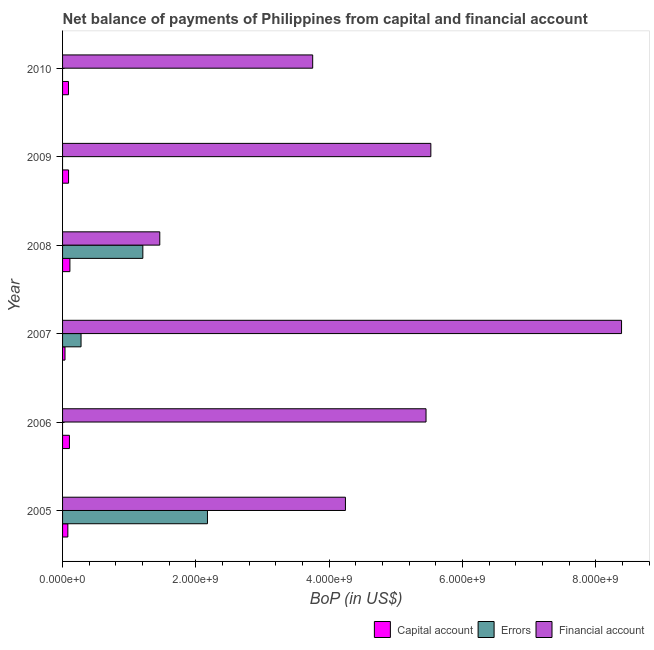How many groups of bars are there?
Give a very brief answer. 6. Are the number of bars per tick equal to the number of legend labels?
Ensure brevity in your answer.  No. How many bars are there on the 3rd tick from the top?
Your response must be concise. 3. What is the label of the 5th group of bars from the top?
Give a very brief answer. 2006. What is the amount of net capital account in 2009?
Your response must be concise. 8.99e+07. Across all years, what is the maximum amount of net capital account?
Offer a terse response. 1.10e+08. What is the total amount of financial account in the graph?
Your answer should be very brief. 2.88e+1. What is the difference between the amount of financial account in 2009 and that in 2010?
Ensure brevity in your answer.  1.77e+09. What is the difference between the amount of financial account in 2008 and the amount of net capital account in 2009?
Give a very brief answer. 1.37e+09. What is the average amount of errors per year?
Make the answer very short. 6.09e+08. In the year 2008, what is the difference between the amount of financial account and amount of net capital account?
Your response must be concise. 1.35e+09. What is the ratio of the amount of financial account in 2007 to that in 2010?
Provide a short and direct response. 2.23. Is the amount of net capital account in 2006 less than that in 2008?
Ensure brevity in your answer.  Yes. What is the difference between the highest and the second highest amount of net capital account?
Provide a short and direct response. 6.96e+06. What is the difference between the highest and the lowest amount of errors?
Ensure brevity in your answer.  2.17e+09. Is the sum of the amount of financial account in 2006 and 2009 greater than the maximum amount of errors across all years?
Offer a very short reply. Yes. Is it the case that in every year, the sum of the amount of net capital account and amount of errors is greater than the amount of financial account?
Your answer should be very brief. No. Are all the bars in the graph horizontal?
Offer a very short reply. Yes. How many years are there in the graph?
Make the answer very short. 6. Does the graph contain grids?
Keep it short and to the point. No. Where does the legend appear in the graph?
Ensure brevity in your answer.  Bottom right. How many legend labels are there?
Give a very brief answer. 3. What is the title of the graph?
Keep it short and to the point. Net balance of payments of Philippines from capital and financial account. What is the label or title of the X-axis?
Keep it short and to the point. BoP (in US$). What is the label or title of the Y-axis?
Provide a short and direct response. Year. What is the BoP (in US$) of Capital account in 2005?
Your answer should be very brief. 7.93e+07. What is the BoP (in US$) of Errors in 2005?
Your answer should be compact. 2.17e+09. What is the BoP (in US$) of Financial account in 2005?
Your answer should be very brief. 4.24e+09. What is the BoP (in US$) of Capital account in 2006?
Make the answer very short. 1.03e+08. What is the BoP (in US$) in Errors in 2006?
Make the answer very short. 0. What is the BoP (in US$) of Financial account in 2006?
Provide a short and direct response. 5.45e+09. What is the BoP (in US$) in Capital account in 2007?
Your response must be concise. 3.64e+07. What is the BoP (in US$) in Errors in 2007?
Offer a very short reply. 2.77e+08. What is the BoP (in US$) of Financial account in 2007?
Make the answer very short. 8.39e+09. What is the BoP (in US$) of Capital account in 2008?
Your answer should be compact. 1.10e+08. What is the BoP (in US$) in Errors in 2008?
Your response must be concise. 1.20e+09. What is the BoP (in US$) in Financial account in 2008?
Your response must be concise. 1.46e+09. What is the BoP (in US$) in Capital account in 2009?
Ensure brevity in your answer.  8.99e+07. What is the BoP (in US$) in Errors in 2009?
Your response must be concise. 0. What is the BoP (in US$) in Financial account in 2009?
Your answer should be very brief. 5.52e+09. What is the BoP (in US$) of Capital account in 2010?
Offer a very short reply. 8.85e+07. What is the BoP (in US$) of Errors in 2010?
Your answer should be compact. 0. What is the BoP (in US$) of Financial account in 2010?
Make the answer very short. 3.75e+09. Across all years, what is the maximum BoP (in US$) in Capital account?
Offer a terse response. 1.10e+08. Across all years, what is the maximum BoP (in US$) in Errors?
Your answer should be very brief. 2.17e+09. Across all years, what is the maximum BoP (in US$) of Financial account?
Ensure brevity in your answer.  8.39e+09. Across all years, what is the minimum BoP (in US$) in Capital account?
Make the answer very short. 3.64e+07. Across all years, what is the minimum BoP (in US$) of Financial account?
Make the answer very short. 1.46e+09. What is the total BoP (in US$) of Capital account in the graph?
Provide a succinct answer. 5.07e+08. What is the total BoP (in US$) in Errors in the graph?
Your answer should be compact. 3.66e+09. What is the total BoP (in US$) in Financial account in the graph?
Your answer should be very brief. 2.88e+1. What is the difference between the BoP (in US$) in Capital account in 2005 and that in 2006?
Your answer should be very brief. -2.38e+07. What is the difference between the BoP (in US$) of Financial account in 2005 and that in 2006?
Give a very brief answer. -1.21e+09. What is the difference between the BoP (in US$) of Capital account in 2005 and that in 2007?
Make the answer very short. 4.28e+07. What is the difference between the BoP (in US$) of Errors in 2005 and that in 2007?
Offer a terse response. 1.90e+09. What is the difference between the BoP (in US$) in Financial account in 2005 and that in 2007?
Make the answer very short. -4.14e+09. What is the difference between the BoP (in US$) in Capital account in 2005 and that in 2008?
Provide a short and direct response. -3.08e+07. What is the difference between the BoP (in US$) in Errors in 2005 and that in 2008?
Keep it short and to the point. 9.69e+08. What is the difference between the BoP (in US$) in Financial account in 2005 and that in 2008?
Ensure brevity in your answer.  2.79e+09. What is the difference between the BoP (in US$) of Capital account in 2005 and that in 2009?
Your answer should be very brief. -1.06e+07. What is the difference between the BoP (in US$) in Financial account in 2005 and that in 2009?
Your answer should be compact. -1.28e+09. What is the difference between the BoP (in US$) of Capital account in 2005 and that in 2010?
Provide a succinct answer. -9.22e+06. What is the difference between the BoP (in US$) in Financial account in 2005 and that in 2010?
Make the answer very short. 4.91e+08. What is the difference between the BoP (in US$) of Capital account in 2006 and that in 2007?
Provide a succinct answer. 6.67e+07. What is the difference between the BoP (in US$) in Financial account in 2006 and that in 2007?
Keep it short and to the point. -2.93e+09. What is the difference between the BoP (in US$) of Capital account in 2006 and that in 2008?
Provide a short and direct response. -6.96e+06. What is the difference between the BoP (in US$) in Financial account in 2006 and that in 2008?
Provide a short and direct response. 3.99e+09. What is the difference between the BoP (in US$) of Capital account in 2006 and that in 2009?
Provide a succinct answer. 1.32e+07. What is the difference between the BoP (in US$) of Financial account in 2006 and that in 2009?
Keep it short and to the point. -7.20e+07. What is the difference between the BoP (in US$) of Capital account in 2006 and that in 2010?
Give a very brief answer. 1.46e+07. What is the difference between the BoP (in US$) in Financial account in 2006 and that in 2010?
Offer a terse response. 1.70e+09. What is the difference between the BoP (in US$) of Capital account in 2007 and that in 2008?
Your response must be concise. -7.36e+07. What is the difference between the BoP (in US$) of Errors in 2007 and that in 2008?
Give a very brief answer. -9.27e+08. What is the difference between the BoP (in US$) of Financial account in 2007 and that in 2008?
Make the answer very short. 6.93e+09. What is the difference between the BoP (in US$) of Capital account in 2007 and that in 2009?
Provide a short and direct response. -5.34e+07. What is the difference between the BoP (in US$) of Financial account in 2007 and that in 2009?
Provide a succinct answer. 2.86e+09. What is the difference between the BoP (in US$) in Capital account in 2007 and that in 2010?
Your response must be concise. -5.21e+07. What is the difference between the BoP (in US$) in Financial account in 2007 and that in 2010?
Your response must be concise. 4.63e+09. What is the difference between the BoP (in US$) in Capital account in 2008 and that in 2009?
Your response must be concise. 2.02e+07. What is the difference between the BoP (in US$) in Financial account in 2008 and that in 2009?
Your response must be concise. -4.07e+09. What is the difference between the BoP (in US$) of Capital account in 2008 and that in 2010?
Your answer should be very brief. 2.16e+07. What is the difference between the BoP (in US$) in Financial account in 2008 and that in 2010?
Offer a very short reply. -2.29e+09. What is the difference between the BoP (in US$) of Capital account in 2009 and that in 2010?
Offer a very short reply. 1.39e+06. What is the difference between the BoP (in US$) of Financial account in 2009 and that in 2010?
Provide a short and direct response. 1.77e+09. What is the difference between the BoP (in US$) in Capital account in 2005 and the BoP (in US$) in Financial account in 2006?
Offer a very short reply. -5.37e+09. What is the difference between the BoP (in US$) in Errors in 2005 and the BoP (in US$) in Financial account in 2006?
Offer a very short reply. -3.28e+09. What is the difference between the BoP (in US$) of Capital account in 2005 and the BoP (in US$) of Errors in 2007?
Your response must be concise. -1.98e+08. What is the difference between the BoP (in US$) of Capital account in 2005 and the BoP (in US$) of Financial account in 2007?
Provide a succinct answer. -8.31e+09. What is the difference between the BoP (in US$) of Errors in 2005 and the BoP (in US$) of Financial account in 2007?
Your answer should be very brief. -6.21e+09. What is the difference between the BoP (in US$) of Capital account in 2005 and the BoP (in US$) of Errors in 2008?
Your response must be concise. -1.13e+09. What is the difference between the BoP (in US$) in Capital account in 2005 and the BoP (in US$) in Financial account in 2008?
Keep it short and to the point. -1.38e+09. What is the difference between the BoP (in US$) in Errors in 2005 and the BoP (in US$) in Financial account in 2008?
Give a very brief answer. 7.15e+08. What is the difference between the BoP (in US$) in Capital account in 2005 and the BoP (in US$) in Financial account in 2009?
Keep it short and to the point. -5.45e+09. What is the difference between the BoP (in US$) in Errors in 2005 and the BoP (in US$) in Financial account in 2009?
Make the answer very short. -3.35e+09. What is the difference between the BoP (in US$) in Capital account in 2005 and the BoP (in US$) in Financial account in 2010?
Offer a terse response. -3.67e+09. What is the difference between the BoP (in US$) of Errors in 2005 and the BoP (in US$) of Financial account in 2010?
Keep it short and to the point. -1.58e+09. What is the difference between the BoP (in US$) in Capital account in 2006 and the BoP (in US$) in Errors in 2007?
Make the answer very short. -1.74e+08. What is the difference between the BoP (in US$) of Capital account in 2006 and the BoP (in US$) of Financial account in 2007?
Offer a very short reply. -8.28e+09. What is the difference between the BoP (in US$) of Capital account in 2006 and the BoP (in US$) of Errors in 2008?
Give a very brief answer. -1.10e+09. What is the difference between the BoP (in US$) in Capital account in 2006 and the BoP (in US$) in Financial account in 2008?
Offer a terse response. -1.36e+09. What is the difference between the BoP (in US$) of Capital account in 2006 and the BoP (in US$) of Financial account in 2009?
Your response must be concise. -5.42e+09. What is the difference between the BoP (in US$) in Capital account in 2006 and the BoP (in US$) in Financial account in 2010?
Give a very brief answer. -3.65e+09. What is the difference between the BoP (in US$) in Capital account in 2007 and the BoP (in US$) in Errors in 2008?
Provide a succinct answer. -1.17e+09. What is the difference between the BoP (in US$) of Capital account in 2007 and the BoP (in US$) of Financial account in 2008?
Your answer should be very brief. -1.42e+09. What is the difference between the BoP (in US$) of Errors in 2007 and the BoP (in US$) of Financial account in 2008?
Provide a short and direct response. -1.18e+09. What is the difference between the BoP (in US$) of Capital account in 2007 and the BoP (in US$) of Financial account in 2009?
Make the answer very short. -5.49e+09. What is the difference between the BoP (in US$) of Errors in 2007 and the BoP (in US$) of Financial account in 2009?
Make the answer very short. -5.25e+09. What is the difference between the BoP (in US$) in Capital account in 2007 and the BoP (in US$) in Financial account in 2010?
Provide a short and direct response. -3.72e+09. What is the difference between the BoP (in US$) in Errors in 2007 and the BoP (in US$) in Financial account in 2010?
Offer a terse response. -3.47e+09. What is the difference between the BoP (in US$) of Capital account in 2008 and the BoP (in US$) of Financial account in 2009?
Keep it short and to the point. -5.41e+09. What is the difference between the BoP (in US$) of Errors in 2008 and the BoP (in US$) of Financial account in 2009?
Your answer should be compact. -4.32e+09. What is the difference between the BoP (in US$) of Capital account in 2008 and the BoP (in US$) of Financial account in 2010?
Ensure brevity in your answer.  -3.64e+09. What is the difference between the BoP (in US$) of Errors in 2008 and the BoP (in US$) of Financial account in 2010?
Make the answer very short. -2.55e+09. What is the difference between the BoP (in US$) in Capital account in 2009 and the BoP (in US$) in Financial account in 2010?
Offer a terse response. -3.66e+09. What is the average BoP (in US$) of Capital account per year?
Give a very brief answer. 8.45e+07. What is the average BoP (in US$) in Errors per year?
Offer a very short reply. 6.09e+08. What is the average BoP (in US$) of Financial account per year?
Give a very brief answer. 4.80e+09. In the year 2005, what is the difference between the BoP (in US$) of Capital account and BoP (in US$) of Errors?
Your answer should be compact. -2.09e+09. In the year 2005, what is the difference between the BoP (in US$) of Capital account and BoP (in US$) of Financial account?
Provide a succinct answer. -4.16e+09. In the year 2005, what is the difference between the BoP (in US$) of Errors and BoP (in US$) of Financial account?
Your response must be concise. -2.07e+09. In the year 2006, what is the difference between the BoP (in US$) of Capital account and BoP (in US$) of Financial account?
Your response must be concise. -5.35e+09. In the year 2007, what is the difference between the BoP (in US$) of Capital account and BoP (in US$) of Errors?
Provide a succinct answer. -2.41e+08. In the year 2007, what is the difference between the BoP (in US$) in Capital account and BoP (in US$) in Financial account?
Give a very brief answer. -8.35e+09. In the year 2007, what is the difference between the BoP (in US$) of Errors and BoP (in US$) of Financial account?
Make the answer very short. -8.11e+09. In the year 2008, what is the difference between the BoP (in US$) of Capital account and BoP (in US$) of Errors?
Provide a succinct answer. -1.09e+09. In the year 2008, what is the difference between the BoP (in US$) in Capital account and BoP (in US$) in Financial account?
Give a very brief answer. -1.35e+09. In the year 2008, what is the difference between the BoP (in US$) of Errors and BoP (in US$) of Financial account?
Your response must be concise. -2.54e+08. In the year 2009, what is the difference between the BoP (in US$) of Capital account and BoP (in US$) of Financial account?
Your answer should be very brief. -5.43e+09. In the year 2010, what is the difference between the BoP (in US$) of Capital account and BoP (in US$) of Financial account?
Provide a succinct answer. -3.66e+09. What is the ratio of the BoP (in US$) of Capital account in 2005 to that in 2006?
Make the answer very short. 0.77. What is the ratio of the BoP (in US$) in Financial account in 2005 to that in 2006?
Your answer should be very brief. 0.78. What is the ratio of the BoP (in US$) in Capital account in 2005 to that in 2007?
Your answer should be compact. 2.18. What is the ratio of the BoP (in US$) of Errors in 2005 to that in 2007?
Give a very brief answer. 7.84. What is the ratio of the BoP (in US$) in Financial account in 2005 to that in 2007?
Keep it short and to the point. 0.51. What is the ratio of the BoP (in US$) in Capital account in 2005 to that in 2008?
Ensure brevity in your answer.  0.72. What is the ratio of the BoP (in US$) in Errors in 2005 to that in 2008?
Your answer should be compact. 1.8. What is the ratio of the BoP (in US$) of Financial account in 2005 to that in 2008?
Offer a terse response. 2.91. What is the ratio of the BoP (in US$) in Capital account in 2005 to that in 2009?
Offer a terse response. 0.88. What is the ratio of the BoP (in US$) in Financial account in 2005 to that in 2009?
Keep it short and to the point. 0.77. What is the ratio of the BoP (in US$) of Capital account in 2005 to that in 2010?
Keep it short and to the point. 0.9. What is the ratio of the BoP (in US$) in Financial account in 2005 to that in 2010?
Ensure brevity in your answer.  1.13. What is the ratio of the BoP (in US$) in Capital account in 2006 to that in 2007?
Offer a terse response. 2.83. What is the ratio of the BoP (in US$) in Financial account in 2006 to that in 2007?
Provide a short and direct response. 0.65. What is the ratio of the BoP (in US$) in Capital account in 2006 to that in 2008?
Your response must be concise. 0.94. What is the ratio of the BoP (in US$) in Financial account in 2006 to that in 2008?
Provide a succinct answer. 3.74. What is the ratio of the BoP (in US$) in Capital account in 2006 to that in 2009?
Your response must be concise. 1.15. What is the ratio of the BoP (in US$) in Capital account in 2006 to that in 2010?
Give a very brief answer. 1.17. What is the ratio of the BoP (in US$) of Financial account in 2006 to that in 2010?
Make the answer very short. 1.45. What is the ratio of the BoP (in US$) of Capital account in 2007 to that in 2008?
Ensure brevity in your answer.  0.33. What is the ratio of the BoP (in US$) of Errors in 2007 to that in 2008?
Provide a succinct answer. 0.23. What is the ratio of the BoP (in US$) of Financial account in 2007 to that in 2008?
Offer a very short reply. 5.75. What is the ratio of the BoP (in US$) in Capital account in 2007 to that in 2009?
Keep it short and to the point. 0.41. What is the ratio of the BoP (in US$) of Financial account in 2007 to that in 2009?
Make the answer very short. 1.52. What is the ratio of the BoP (in US$) of Capital account in 2007 to that in 2010?
Give a very brief answer. 0.41. What is the ratio of the BoP (in US$) of Financial account in 2007 to that in 2010?
Ensure brevity in your answer.  2.23. What is the ratio of the BoP (in US$) in Capital account in 2008 to that in 2009?
Make the answer very short. 1.22. What is the ratio of the BoP (in US$) of Financial account in 2008 to that in 2009?
Offer a terse response. 0.26. What is the ratio of the BoP (in US$) in Capital account in 2008 to that in 2010?
Offer a very short reply. 1.24. What is the ratio of the BoP (in US$) in Financial account in 2008 to that in 2010?
Give a very brief answer. 0.39. What is the ratio of the BoP (in US$) in Capital account in 2009 to that in 2010?
Offer a terse response. 1.02. What is the ratio of the BoP (in US$) in Financial account in 2009 to that in 2010?
Keep it short and to the point. 1.47. What is the difference between the highest and the second highest BoP (in US$) in Capital account?
Your answer should be compact. 6.96e+06. What is the difference between the highest and the second highest BoP (in US$) of Errors?
Make the answer very short. 9.69e+08. What is the difference between the highest and the second highest BoP (in US$) in Financial account?
Provide a short and direct response. 2.86e+09. What is the difference between the highest and the lowest BoP (in US$) of Capital account?
Keep it short and to the point. 7.36e+07. What is the difference between the highest and the lowest BoP (in US$) in Errors?
Ensure brevity in your answer.  2.17e+09. What is the difference between the highest and the lowest BoP (in US$) of Financial account?
Give a very brief answer. 6.93e+09. 